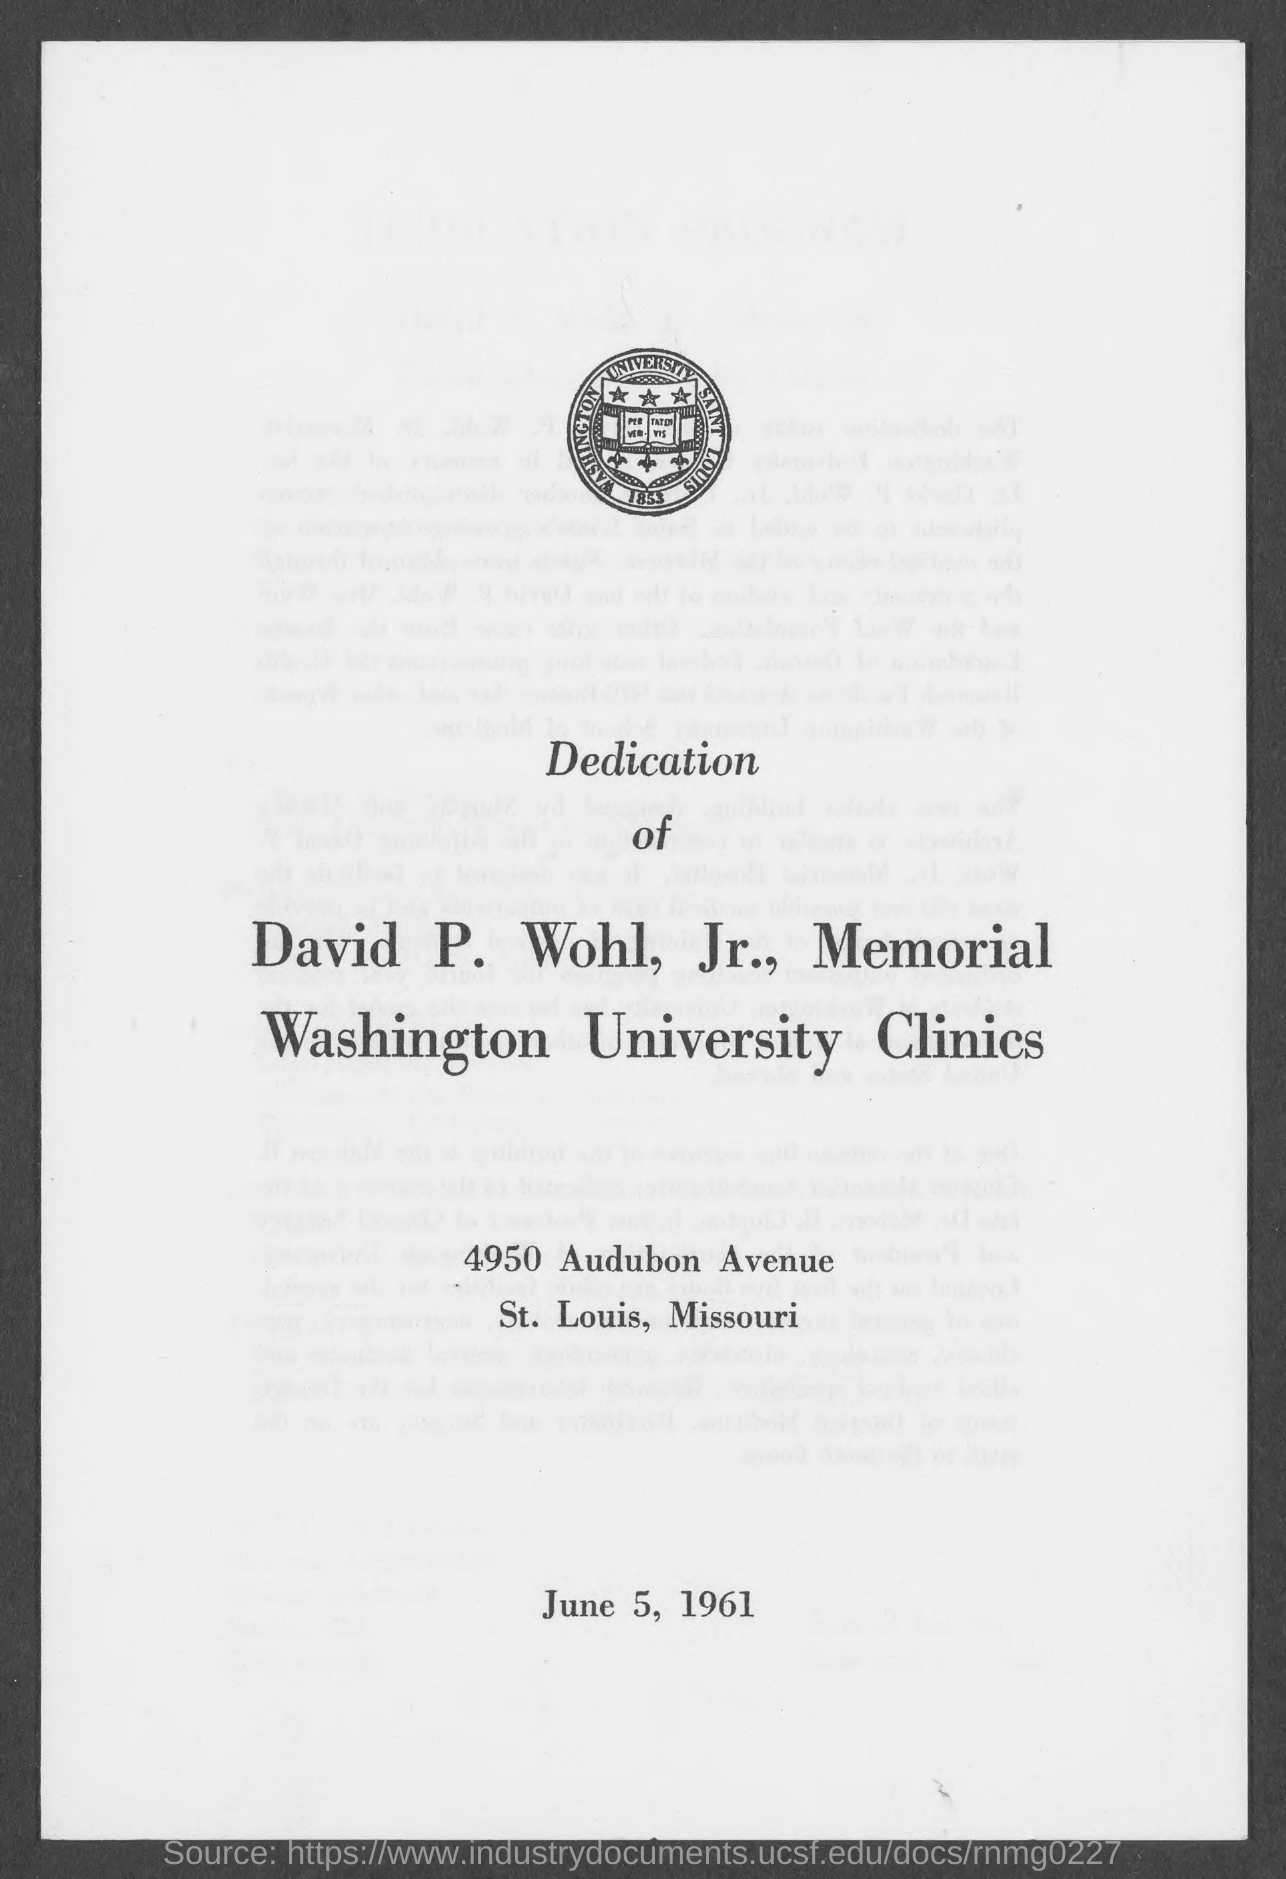What is the date mentioned in the given page ?
Give a very brief answer. June 5, 1961. 